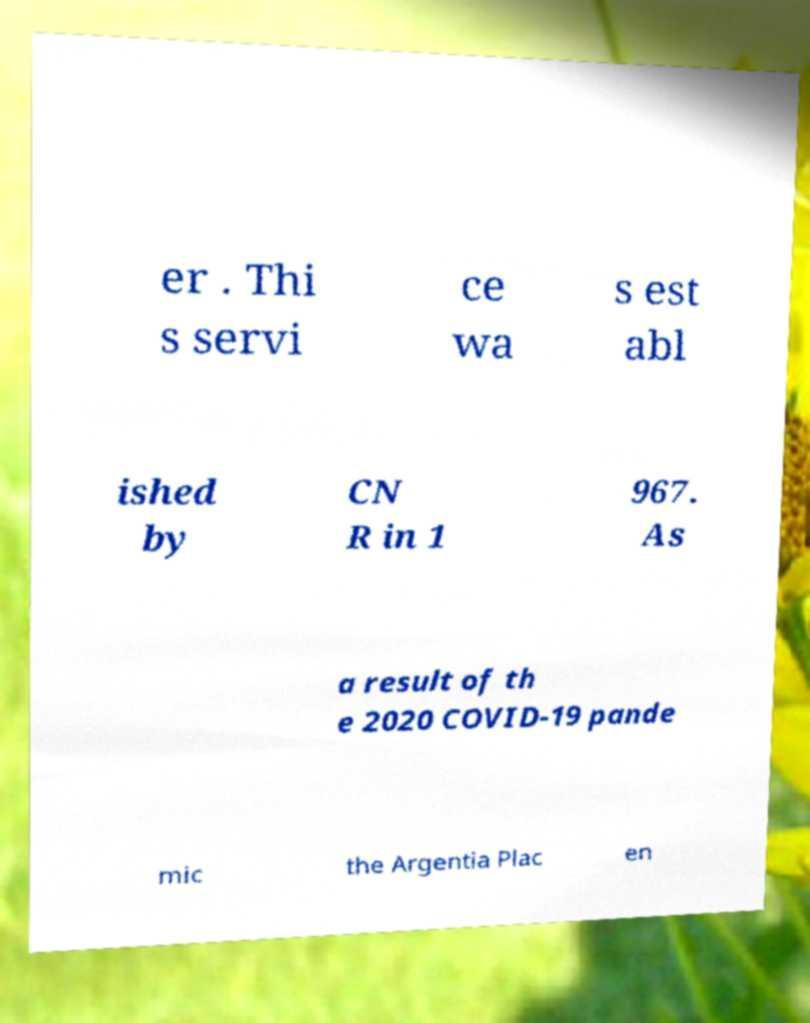What messages or text are displayed in this image? I need them in a readable, typed format. er . Thi s servi ce wa s est abl ished by CN R in 1 967. As a result of th e 2020 COVID-19 pande mic the Argentia Plac en 